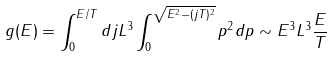<formula> <loc_0><loc_0><loc_500><loc_500>g ( E ) = \int _ { 0 } ^ { E / T } d j L ^ { 3 } \int _ { 0 } ^ { \sqrt { E ^ { 2 } - ( j T ) ^ { 2 } } } p ^ { 2 } d p \sim E ^ { 3 } L ^ { 3 } \frac { E } { T }</formula> 